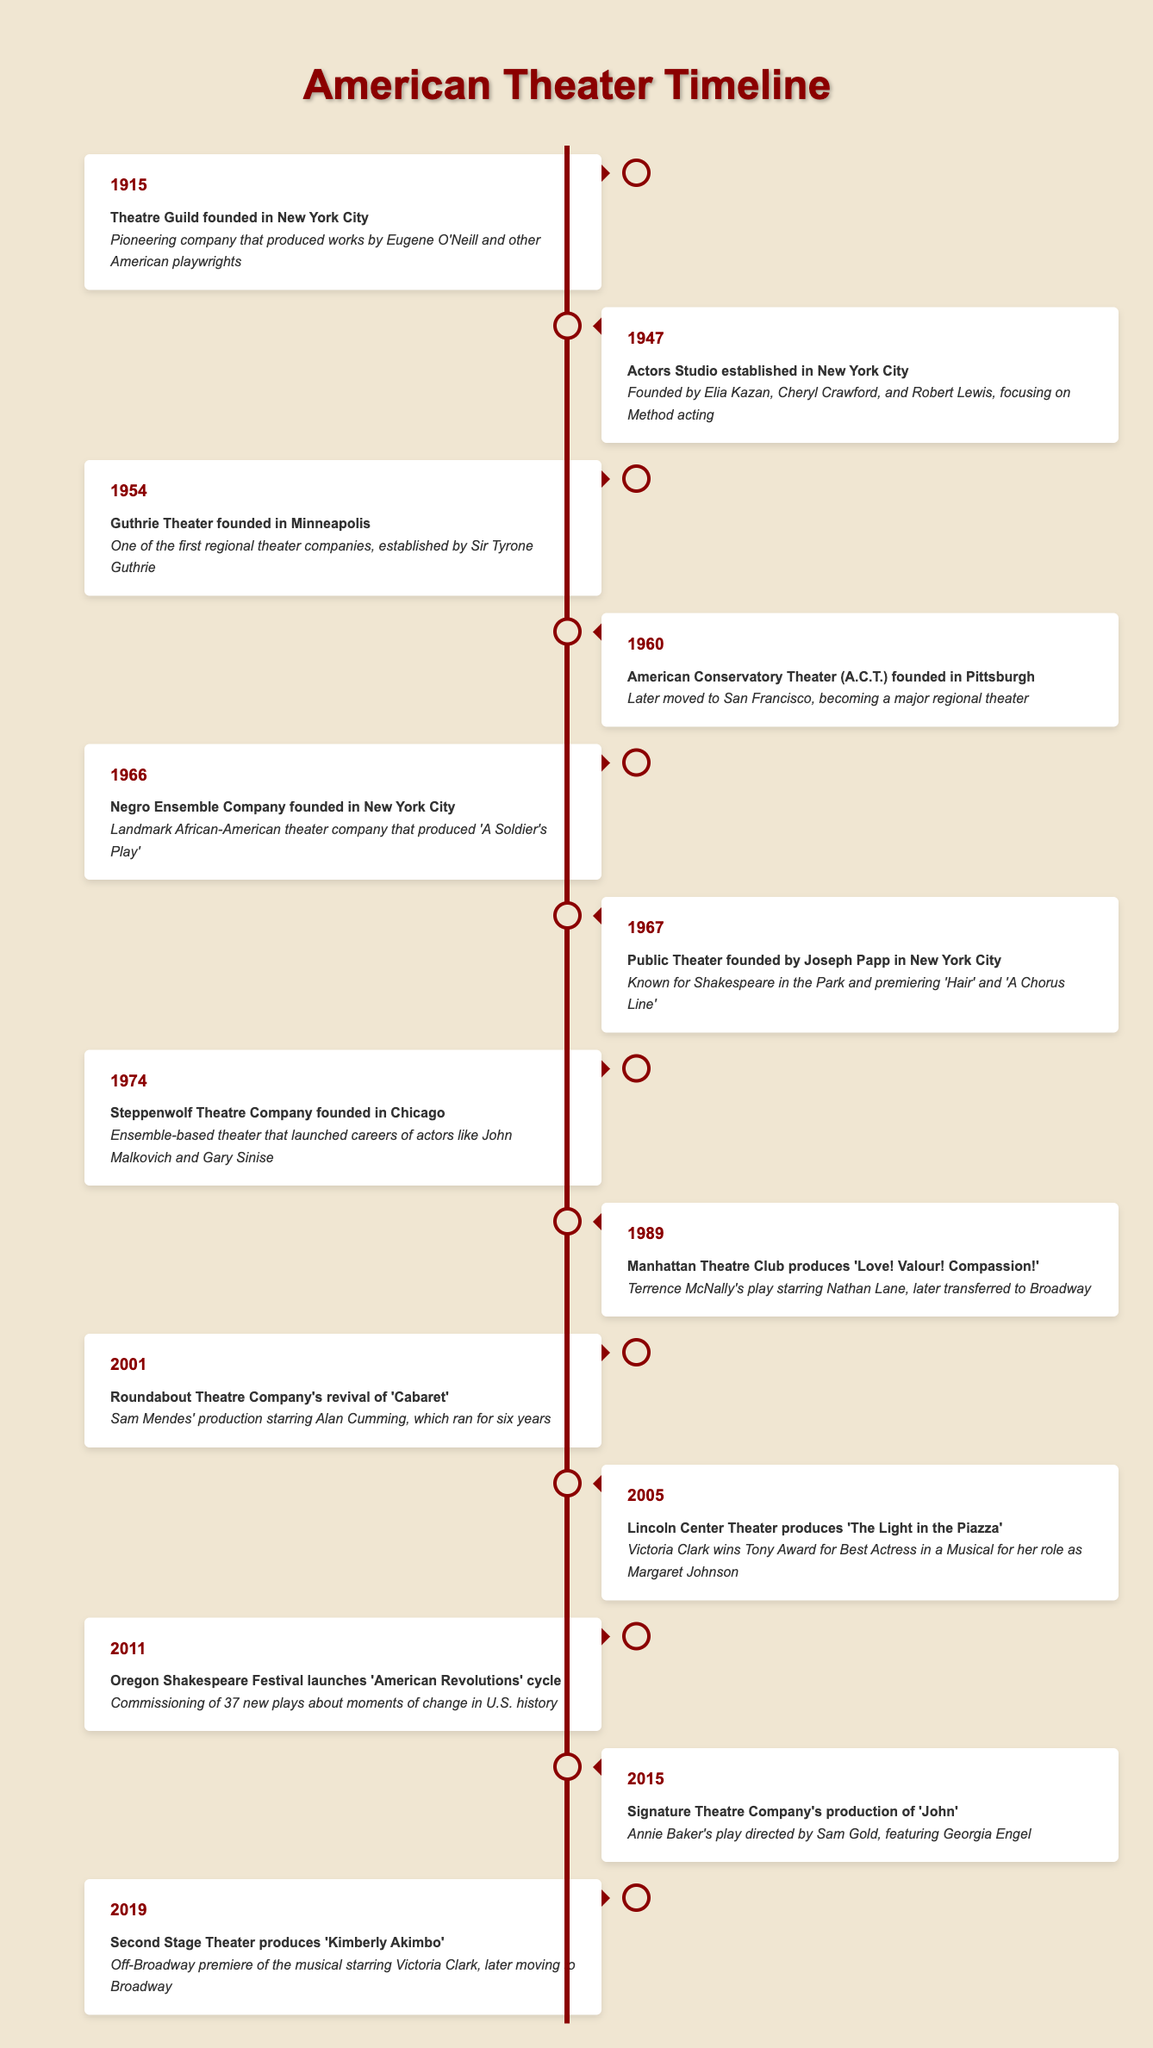What year was the Theatre Guild founded? The Theatre Guild is listed in the timeline under the year 1915.
Answer: 1915 Which company is known for launching careers of actors like John Malkovich and Gary Sinise? The Steppenwolf Theatre Company is mentioned in 1974 as an ensemble-based theater that launched these actors' careers.
Answer: Steppenwolf Theatre Company How many years passed between the founding of the Actors Studio and the Guthrie Theater? The Actors Studio was established in 1947 and the Guthrie Theater was founded in 1954. The difference between these years is 1954 - 1947 = 7 years.
Answer: 7 years True or False: The Public Theater was established before the Negro Ensemble Company. The timeline shows that the Public Theater was founded in 1967, while the Negro Ensemble Company was founded in 1966. Since 1966 is before 1967, the statement is false.
Answer: False Which production at Lincoln Center Theater won Victoria Clark a Tony Award? The year 2005 lists Lincoln Center Theater's production of "The Light in the Piazza," which states that Victoria Clark won the Tony Award for Best Actress in a Musical for her role in that production.
Answer: The Light in the Piazza What are the two landmark productions mentioned in 1967 and what are they known for? In 1967, the timeline mentions the founding of the Public Theater known for Shakespeare in the Park and premiering works such as "Hair" and "A Chorus Line."
Answer: Public Theater, known for Shakespeare in the Park and premiering 'Hair' and 'A Chorus Line' Which company produced 'Kimberly Akimbo' and what significance does it have in Victoria Clark's career? The timeline indicates that Second Stage Theater produced "Kimberly Akimbo" in 2019, which is significant as it was an Off-Broadway premiere starring Victoria Clark before moving to Broadway.
Answer: Second Stage Theater; it's significant for starring Victoria Clark How many major theater companies were founded between 1915 and 1974? Looking at the timeline, the companies founded during this period include the Theatre Guild (1915), the Actors Studio (1947), Guthrie Theater (1954), American Conservatory Theater (1960), Negro Ensemble Company (1966), and Steppenwolf Theatre Company (1974). This totals to 6 companies founded.
Answer: 6 companies 